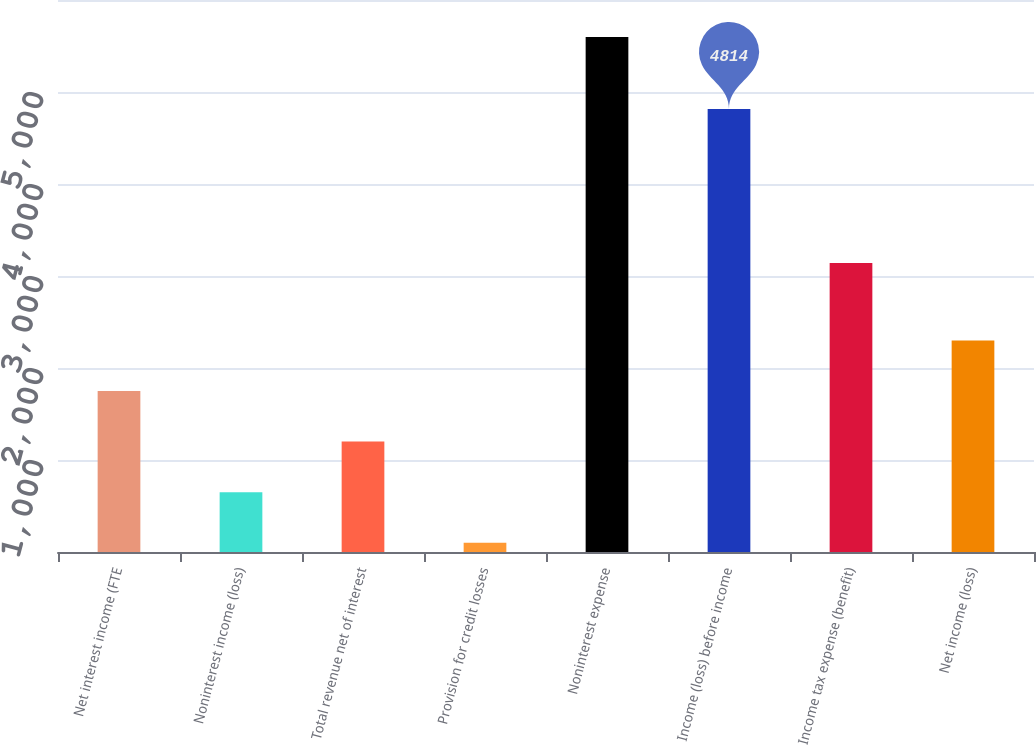Convert chart. <chart><loc_0><loc_0><loc_500><loc_500><bar_chart><fcel>Net interest income (FTE<fcel>Noninterest income (loss)<fcel>Total revenue net of interest<fcel>Provision for credit losses<fcel>Noninterest expense<fcel>Income (loss) before income<fcel>Income tax expense (benefit)<fcel>Net income (loss)<nl><fcel>1749.7<fcel>649.9<fcel>1199.8<fcel>100<fcel>5599<fcel>4814<fcel>3142<fcel>2299.6<nl></chart> 